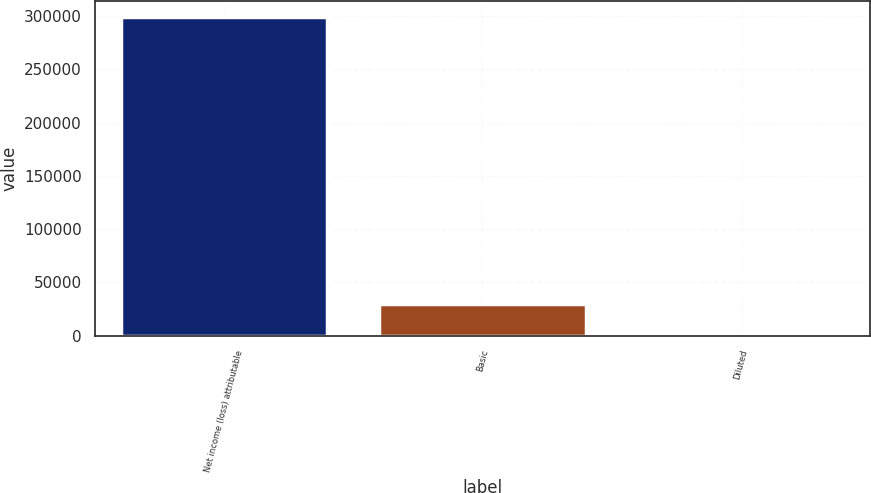<chart> <loc_0><loc_0><loc_500><loc_500><bar_chart><fcel>Net income (loss) attributable<fcel>Basic<fcel>Diluted<nl><fcel>299526<fcel>29953.5<fcel>1.03<nl></chart> 